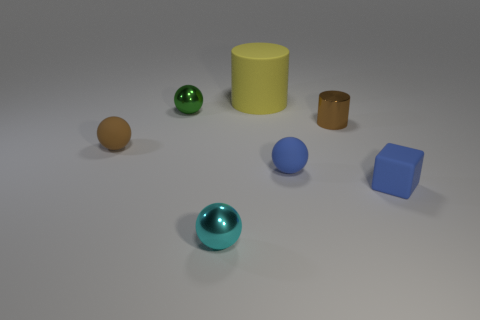Subtract all blue balls. How many balls are left? 3 Add 1 small objects. How many objects exist? 8 Subtract all blue balls. How many balls are left? 3 Subtract all cubes. How many objects are left? 6 Add 5 small blue blocks. How many small blue blocks exist? 6 Subtract 1 yellow cylinders. How many objects are left? 6 Subtract 2 cylinders. How many cylinders are left? 0 Subtract all brown spheres. Subtract all yellow cylinders. How many spheres are left? 3 Subtract all brown balls. How many gray cylinders are left? 0 Subtract all small brown metal balls. Subtract all metallic cylinders. How many objects are left? 6 